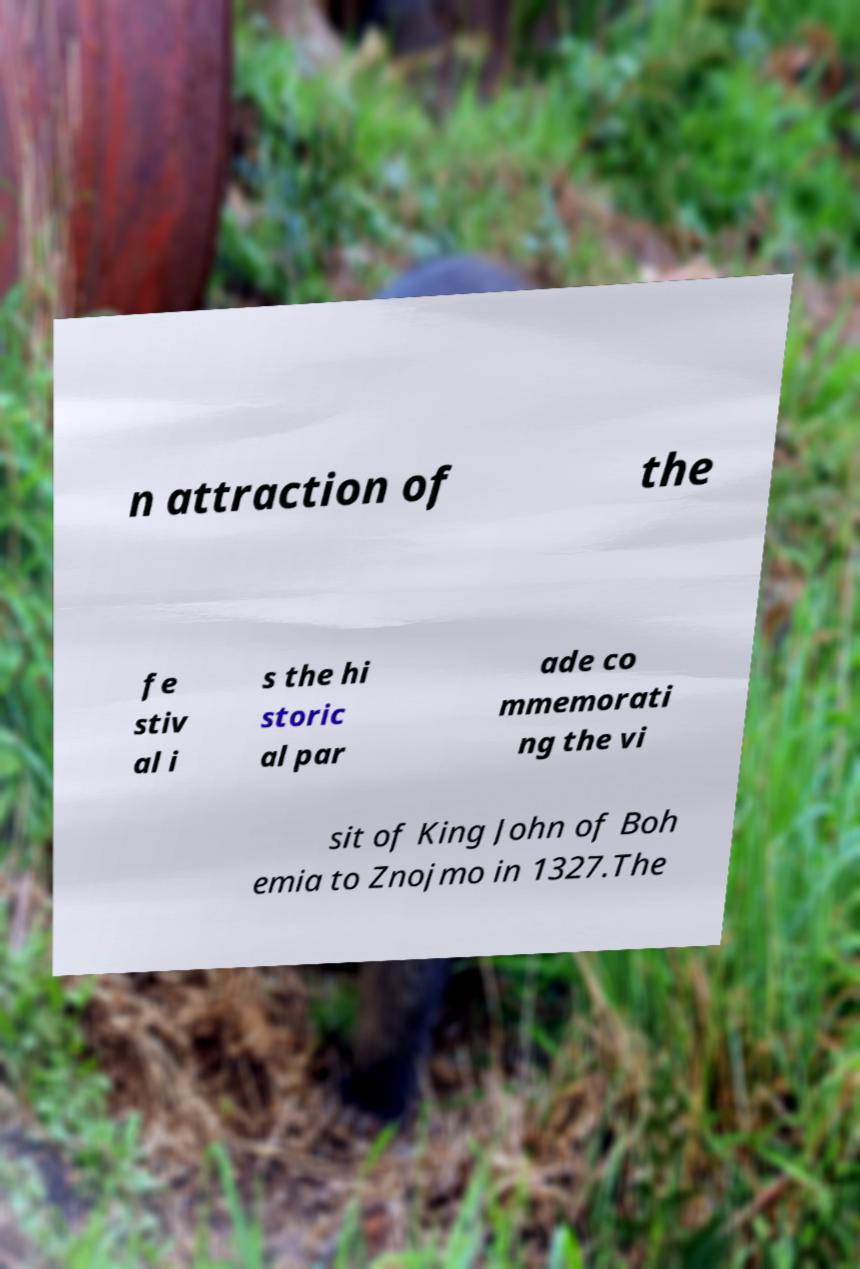Could you extract and type out the text from this image? n attraction of the fe stiv al i s the hi storic al par ade co mmemorati ng the vi sit of King John of Boh emia to Znojmo in 1327.The 